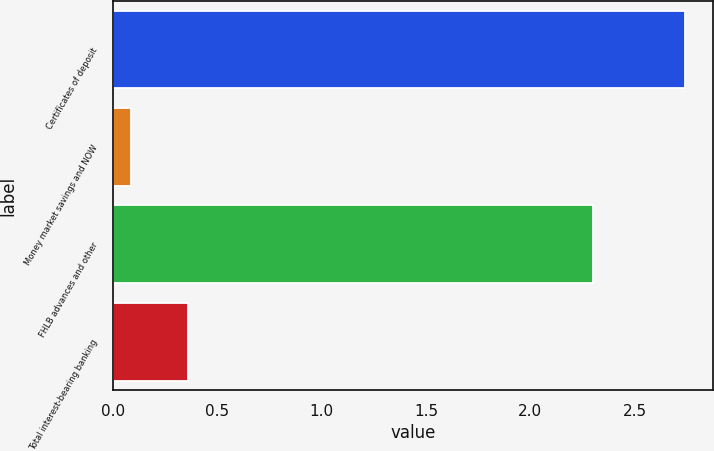Convert chart. <chart><loc_0><loc_0><loc_500><loc_500><bar_chart><fcel>Certificates of deposit<fcel>Money market savings and NOW<fcel>FHLB advances and other<fcel>Total interest-bearing banking<nl><fcel>2.74<fcel>0.09<fcel>2.3<fcel>0.36<nl></chart> 